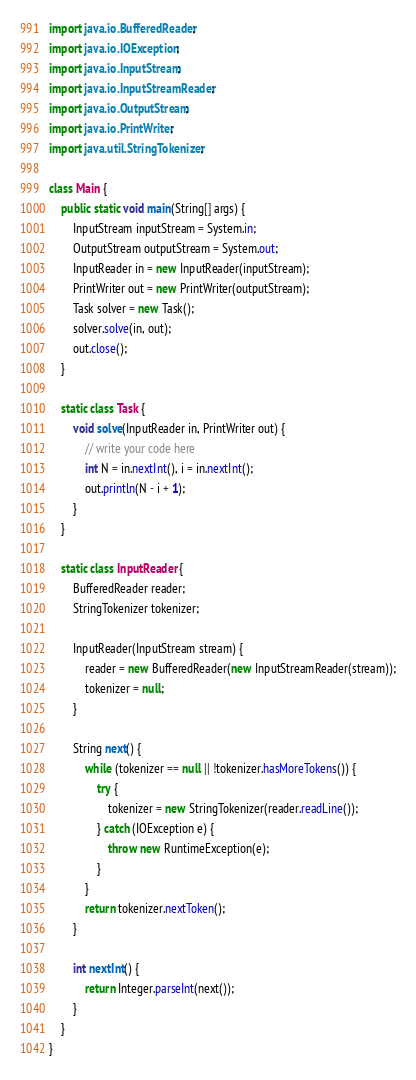Convert code to text. <code><loc_0><loc_0><loc_500><loc_500><_Java_>import java.io.BufferedReader;
import java.io.IOException;
import java.io.InputStream;
import java.io.InputStreamReader;
import java.io.OutputStream;
import java.io.PrintWriter;
import java.util.StringTokenizer;

class Main {
    public static void main(String[] args) {
        InputStream inputStream = System.in;
        OutputStream outputStream = System.out;
        InputReader in = new InputReader(inputStream);
        PrintWriter out = new PrintWriter(outputStream);
        Task solver = new Task();
        solver.solve(in, out);
        out.close();
    }

    static class Task {
        void solve(InputReader in, PrintWriter out) {
            // write your code here
            int N = in.nextInt(), i = in.nextInt();
            out.println(N - i + 1);
        }
    }

    static class InputReader {
        BufferedReader reader;
        StringTokenizer tokenizer;

        InputReader(InputStream stream) {
            reader = new BufferedReader(new InputStreamReader(stream));
            tokenizer = null;
        }

        String next() {
            while (tokenizer == null || !tokenizer.hasMoreTokens()) {
                try {
                    tokenizer = new StringTokenizer(reader.readLine());
                } catch (IOException e) {
                    throw new RuntimeException(e);
                }
            }
            return tokenizer.nextToken();
        }

        int nextInt() {
            return Integer.parseInt(next());
        }
    }
}
</code> 